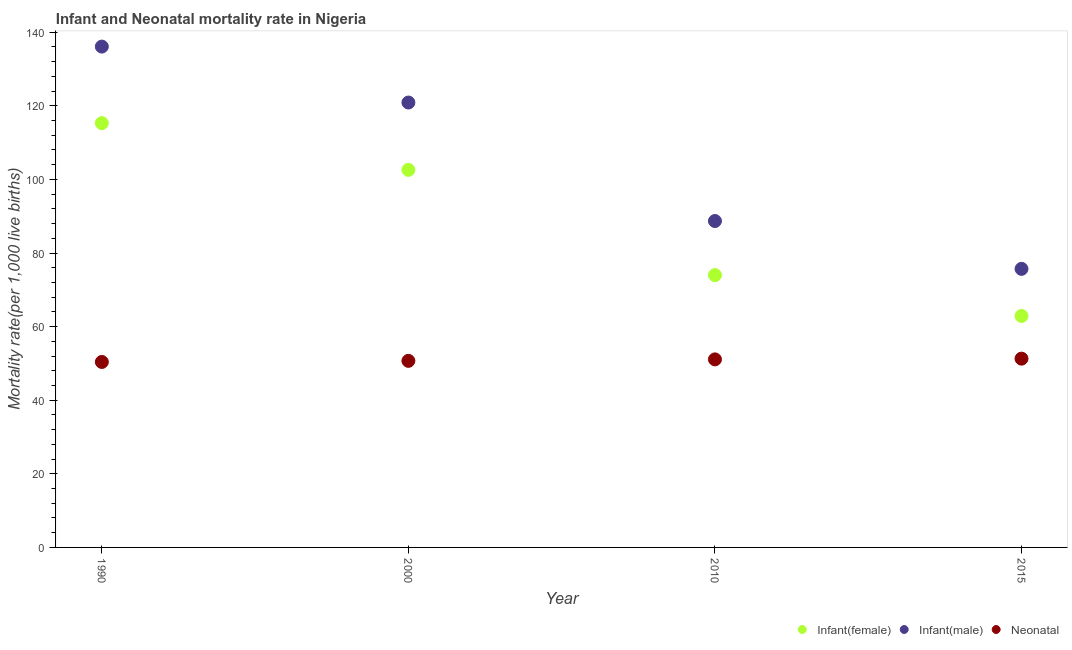Is the number of dotlines equal to the number of legend labels?
Your answer should be compact. Yes. What is the infant mortality rate(female) in 2000?
Ensure brevity in your answer.  102.6. Across all years, what is the maximum neonatal mortality rate?
Provide a short and direct response. 51.3. Across all years, what is the minimum neonatal mortality rate?
Your answer should be very brief. 50.4. In which year was the infant mortality rate(female) minimum?
Provide a succinct answer. 2015. What is the total neonatal mortality rate in the graph?
Your answer should be compact. 203.5. What is the difference between the infant mortality rate(male) in 2010 and that in 2015?
Provide a short and direct response. 13. What is the average neonatal mortality rate per year?
Make the answer very short. 50.88. In the year 2000, what is the difference between the infant mortality rate(male) and neonatal mortality rate?
Give a very brief answer. 70.2. In how many years, is the neonatal mortality rate greater than 100?
Your response must be concise. 0. What is the ratio of the neonatal mortality rate in 2010 to that in 2015?
Your response must be concise. 1. Is the infant mortality rate(female) in 2010 less than that in 2015?
Ensure brevity in your answer.  No. Is the difference between the neonatal mortality rate in 1990 and 2000 greater than the difference between the infant mortality rate(male) in 1990 and 2000?
Your response must be concise. No. What is the difference between the highest and the second highest neonatal mortality rate?
Provide a succinct answer. 0.2. What is the difference between the highest and the lowest neonatal mortality rate?
Offer a terse response. 0.9. Is the sum of the infant mortality rate(male) in 1990 and 2015 greater than the maximum neonatal mortality rate across all years?
Your answer should be very brief. Yes. Is it the case that in every year, the sum of the infant mortality rate(female) and infant mortality rate(male) is greater than the neonatal mortality rate?
Keep it short and to the point. Yes. Does the infant mortality rate(male) monotonically increase over the years?
Your answer should be compact. No. Is the infant mortality rate(female) strictly greater than the neonatal mortality rate over the years?
Your response must be concise. Yes. Is the infant mortality rate(male) strictly less than the neonatal mortality rate over the years?
Make the answer very short. No. Are the values on the major ticks of Y-axis written in scientific E-notation?
Offer a terse response. No. Does the graph contain grids?
Provide a short and direct response. No. Where does the legend appear in the graph?
Your response must be concise. Bottom right. How many legend labels are there?
Provide a succinct answer. 3. How are the legend labels stacked?
Offer a very short reply. Horizontal. What is the title of the graph?
Your answer should be compact. Infant and Neonatal mortality rate in Nigeria. What is the label or title of the Y-axis?
Your answer should be very brief. Mortality rate(per 1,0 live births). What is the Mortality rate(per 1,000 live births) in Infant(female) in 1990?
Ensure brevity in your answer.  115.3. What is the Mortality rate(per 1,000 live births) of Infant(male) in 1990?
Your answer should be compact. 136.1. What is the Mortality rate(per 1,000 live births) of Neonatal  in 1990?
Keep it short and to the point. 50.4. What is the Mortality rate(per 1,000 live births) in Infant(female) in 2000?
Your answer should be compact. 102.6. What is the Mortality rate(per 1,000 live births) of Infant(male) in 2000?
Keep it short and to the point. 120.9. What is the Mortality rate(per 1,000 live births) of Neonatal  in 2000?
Give a very brief answer. 50.7. What is the Mortality rate(per 1,000 live births) in Infant(male) in 2010?
Offer a terse response. 88.7. What is the Mortality rate(per 1,000 live births) in Neonatal  in 2010?
Make the answer very short. 51.1. What is the Mortality rate(per 1,000 live births) of Infant(female) in 2015?
Your answer should be compact. 62.9. What is the Mortality rate(per 1,000 live births) in Infant(male) in 2015?
Offer a terse response. 75.7. What is the Mortality rate(per 1,000 live births) of Neonatal  in 2015?
Offer a very short reply. 51.3. Across all years, what is the maximum Mortality rate(per 1,000 live births) of Infant(female)?
Offer a terse response. 115.3. Across all years, what is the maximum Mortality rate(per 1,000 live births) in Infant(male)?
Your answer should be compact. 136.1. Across all years, what is the maximum Mortality rate(per 1,000 live births) of Neonatal ?
Offer a terse response. 51.3. Across all years, what is the minimum Mortality rate(per 1,000 live births) of Infant(female)?
Give a very brief answer. 62.9. Across all years, what is the minimum Mortality rate(per 1,000 live births) in Infant(male)?
Your answer should be very brief. 75.7. Across all years, what is the minimum Mortality rate(per 1,000 live births) of Neonatal ?
Your response must be concise. 50.4. What is the total Mortality rate(per 1,000 live births) of Infant(female) in the graph?
Provide a succinct answer. 354.8. What is the total Mortality rate(per 1,000 live births) of Infant(male) in the graph?
Ensure brevity in your answer.  421.4. What is the total Mortality rate(per 1,000 live births) in Neonatal  in the graph?
Ensure brevity in your answer.  203.5. What is the difference between the Mortality rate(per 1,000 live births) of Infant(female) in 1990 and that in 2000?
Keep it short and to the point. 12.7. What is the difference between the Mortality rate(per 1,000 live births) in Infant(female) in 1990 and that in 2010?
Provide a succinct answer. 41.3. What is the difference between the Mortality rate(per 1,000 live births) of Infant(male) in 1990 and that in 2010?
Keep it short and to the point. 47.4. What is the difference between the Mortality rate(per 1,000 live births) in Neonatal  in 1990 and that in 2010?
Offer a terse response. -0.7. What is the difference between the Mortality rate(per 1,000 live births) of Infant(female) in 1990 and that in 2015?
Your response must be concise. 52.4. What is the difference between the Mortality rate(per 1,000 live births) of Infant(male) in 1990 and that in 2015?
Give a very brief answer. 60.4. What is the difference between the Mortality rate(per 1,000 live births) of Infant(female) in 2000 and that in 2010?
Keep it short and to the point. 28.6. What is the difference between the Mortality rate(per 1,000 live births) in Infant(male) in 2000 and that in 2010?
Ensure brevity in your answer.  32.2. What is the difference between the Mortality rate(per 1,000 live births) of Neonatal  in 2000 and that in 2010?
Provide a succinct answer. -0.4. What is the difference between the Mortality rate(per 1,000 live births) in Infant(female) in 2000 and that in 2015?
Ensure brevity in your answer.  39.7. What is the difference between the Mortality rate(per 1,000 live births) of Infant(male) in 2000 and that in 2015?
Offer a very short reply. 45.2. What is the difference between the Mortality rate(per 1,000 live births) of Neonatal  in 2000 and that in 2015?
Your answer should be compact. -0.6. What is the difference between the Mortality rate(per 1,000 live births) of Infant(male) in 2010 and that in 2015?
Give a very brief answer. 13. What is the difference between the Mortality rate(per 1,000 live births) of Infant(female) in 1990 and the Mortality rate(per 1,000 live births) of Neonatal  in 2000?
Give a very brief answer. 64.6. What is the difference between the Mortality rate(per 1,000 live births) in Infant(male) in 1990 and the Mortality rate(per 1,000 live births) in Neonatal  in 2000?
Give a very brief answer. 85.4. What is the difference between the Mortality rate(per 1,000 live births) of Infant(female) in 1990 and the Mortality rate(per 1,000 live births) of Infant(male) in 2010?
Offer a terse response. 26.6. What is the difference between the Mortality rate(per 1,000 live births) of Infant(female) in 1990 and the Mortality rate(per 1,000 live births) of Neonatal  in 2010?
Offer a very short reply. 64.2. What is the difference between the Mortality rate(per 1,000 live births) of Infant(male) in 1990 and the Mortality rate(per 1,000 live births) of Neonatal  in 2010?
Keep it short and to the point. 85. What is the difference between the Mortality rate(per 1,000 live births) in Infant(female) in 1990 and the Mortality rate(per 1,000 live births) in Infant(male) in 2015?
Make the answer very short. 39.6. What is the difference between the Mortality rate(per 1,000 live births) in Infant(male) in 1990 and the Mortality rate(per 1,000 live births) in Neonatal  in 2015?
Your answer should be very brief. 84.8. What is the difference between the Mortality rate(per 1,000 live births) in Infant(female) in 2000 and the Mortality rate(per 1,000 live births) in Neonatal  in 2010?
Give a very brief answer. 51.5. What is the difference between the Mortality rate(per 1,000 live births) of Infant(male) in 2000 and the Mortality rate(per 1,000 live births) of Neonatal  in 2010?
Ensure brevity in your answer.  69.8. What is the difference between the Mortality rate(per 1,000 live births) of Infant(female) in 2000 and the Mortality rate(per 1,000 live births) of Infant(male) in 2015?
Your answer should be very brief. 26.9. What is the difference between the Mortality rate(per 1,000 live births) of Infant(female) in 2000 and the Mortality rate(per 1,000 live births) of Neonatal  in 2015?
Your answer should be compact. 51.3. What is the difference between the Mortality rate(per 1,000 live births) in Infant(male) in 2000 and the Mortality rate(per 1,000 live births) in Neonatal  in 2015?
Your response must be concise. 69.6. What is the difference between the Mortality rate(per 1,000 live births) of Infant(female) in 2010 and the Mortality rate(per 1,000 live births) of Infant(male) in 2015?
Keep it short and to the point. -1.7. What is the difference between the Mortality rate(per 1,000 live births) of Infant(female) in 2010 and the Mortality rate(per 1,000 live births) of Neonatal  in 2015?
Your answer should be compact. 22.7. What is the difference between the Mortality rate(per 1,000 live births) of Infant(male) in 2010 and the Mortality rate(per 1,000 live births) of Neonatal  in 2015?
Your answer should be compact. 37.4. What is the average Mortality rate(per 1,000 live births) in Infant(female) per year?
Your answer should be compact. 88.7. What is the average Mortality rate(per 1,000 live births) of Infant(male) per year?
Your answer should be very brief. 105.35. What is the average Mortality rate(per 1,000 live births) of Neonatal  per year?
Provide a succinct answer. 50.88. In the year 1990, what is the difference between the Mortality rate(per 1,000 live births) of Infant(female) and Mortality rate(per 1,000 live births) of Infant(male)?
Offer a terse response. -20.8. In the year 1990, what is the difference between the Mortality rate(per 1,000 live births) in Infant(female) and Mortality rate(per 1,000 live births) in Neonatal ?
Your response must be concise. 64.9. In the year 1990, what is the difference between the Mortality rate(per 1,000 live births) of Infant(male) and Mortality rate(per 1,000 live births) of Neonatal ?
Your response must be concise. 85.7. In the year 2000, what is the difference between the Mortality rate(per 1,000 live births) of Infant(female) and Mortality rate(per 1,000 live births) of Infant(male)?
Ensure brevity in your answer.  -18.3. In the year 2000, what is the difference between the Mortality rate(per 1,000 live births) in Infant(female) and Mortality rate(per 1,000 live births) in Neonatal ?
Provide a succinct answer. 51.9. In the year 2000, what is the difference between the Mortality rate(per 1,000 live births) of Infant(male) and Mortality rate(per 1,000 live births) of Neonatal ?
Give a very brief answer. 70.2. In the year 2010, what is the difference between the Mortality rate(per 1,000 live births) in Infant(female) and Mortality rate(per 1,000 live births) in Infant(male)?
Your response must be concise. -14.7. In the year 2010, what is the difference between the Mortality rate(per 1,000 live births) of Infant(female) and Mortality rate(per 1,000 live births) of Neonatal ?
Offer a terse response. 22.9. In the year 2010, what is the difference between the Mortality rate(per 1,000 live births) of Infant(male) and Mortality rate(per 1,000 live births) of Neonatal ?
Provide a short and direct response. 37.6. In the year 2015, what is the difference between the Mortality rate(per 1,000 live births) of Infant(female) and Mortality rate(per 1,000 live births) of Neonatal ?
Ensure brevity in your answer.  11.6. In the year 2015, what is the difference between the Mortality rate(per 1,000 live births) of Infant(male) and Mortality rate(per 1,000 live births) of Neonatal ?
Make the answer very short. 24.4. What is the ratio of the Mortality rate(per 1,000 live births) in Infant(female) in 1990 to that in 2000?
Offer a very short reply. 1.12. What is the ratio of the Mortality rate(per 1,000 live births) in Infant(male) in 1990 to that in 2000?
Ensure brevity in your answer.  1.13. What is the ratio of the Mortality rate(per 1,000 live births) in Neonatal  in 1990 to that in 2000?
Your answer should be compact. 0.99. What is the ratio of the Mortality rate(per 1,000 live births) of Infant(female) in 1990 to that in 2010?
Offer a very short reply. 1.56. What is the ratio of the Mortality rate(per 1,000 live births) in Infant(male) in 1990 to that in 2010?
Provide a short and direct response. 1.53. What is the ratio of the Mortality rate(per 1,000 live births) in Neonatal  in 1990 to that in 2010?
Provide a short and direct response. 0.99. What is the ratio of the Mortality rate(per 1,000 live births) of Infant(female) in 1990 to that in 2015?
Keep it short and to the point. 1.83. What is the ratio of the Mortality rate(per 1,000 live births) in Infant(male) in 1990 to that in 2015?
Give a very brief answer. 1.8. What is the ratio of the Mortality rate(per 1,000 live births) of Neonatal  in 1990 to that in 2015?
Make the answer very short. 0.98. What is the ratio of the Mortality rate(per 1,000 live births) in Infant(female) in 2000 to that in 2010?
Make the answer very short. 1.39. What is the ratio of the Mortality rate(per 1,000 live births) of Infant(male) in 2000 to that in 2010?
Offer a very short reply. 1.36. What is the ratio of the Mortality rate(per 1,000 live births) of Infant(female) in 2000 to that in 2015?
Give a very brief answer. 1.63. What is the ratio of the Mortality rate(per 1,000 live births) of Infant(male) in 2000 to that in 2015?
Provide a short and direct response. 1.6. What is the ratio of the Mortality rate(per 1,000 live births) in Neonatal  in 2000 to that in 2015?
Ensure brevity in your answer.  0.99. What is the ratio of the Mortality rate(per 1,000 live births) of Infant(female) in 2010 to that in 2015?
Offer a terse response. 1.18. What is the ratio of the Mortality rate(per 1,000 live births) in Infant(male) in 2010 to that in 2015?
Your answer should be compact. 1.17. What is the ratio of the Mortality rate(per 1,000 live births) of Neonatal  in 2010 to that in 2015?
Your answer should be very brief. 1. What is the difference between the highest and the lowest Mortality rate(per 1,000 live births) in Infant(female)?
Ensure brevity in your answer.  52.4. What is the difference between the highest and the lowest Mortality rate(per 1,000 live births) of Infant(male)?
Your answer should be compact. 60.4. What is the difference between the highest and the lowest Mortality rate(per 1,000 live births) in Neonatal ?
Your answer should be very brief. 0.9. 